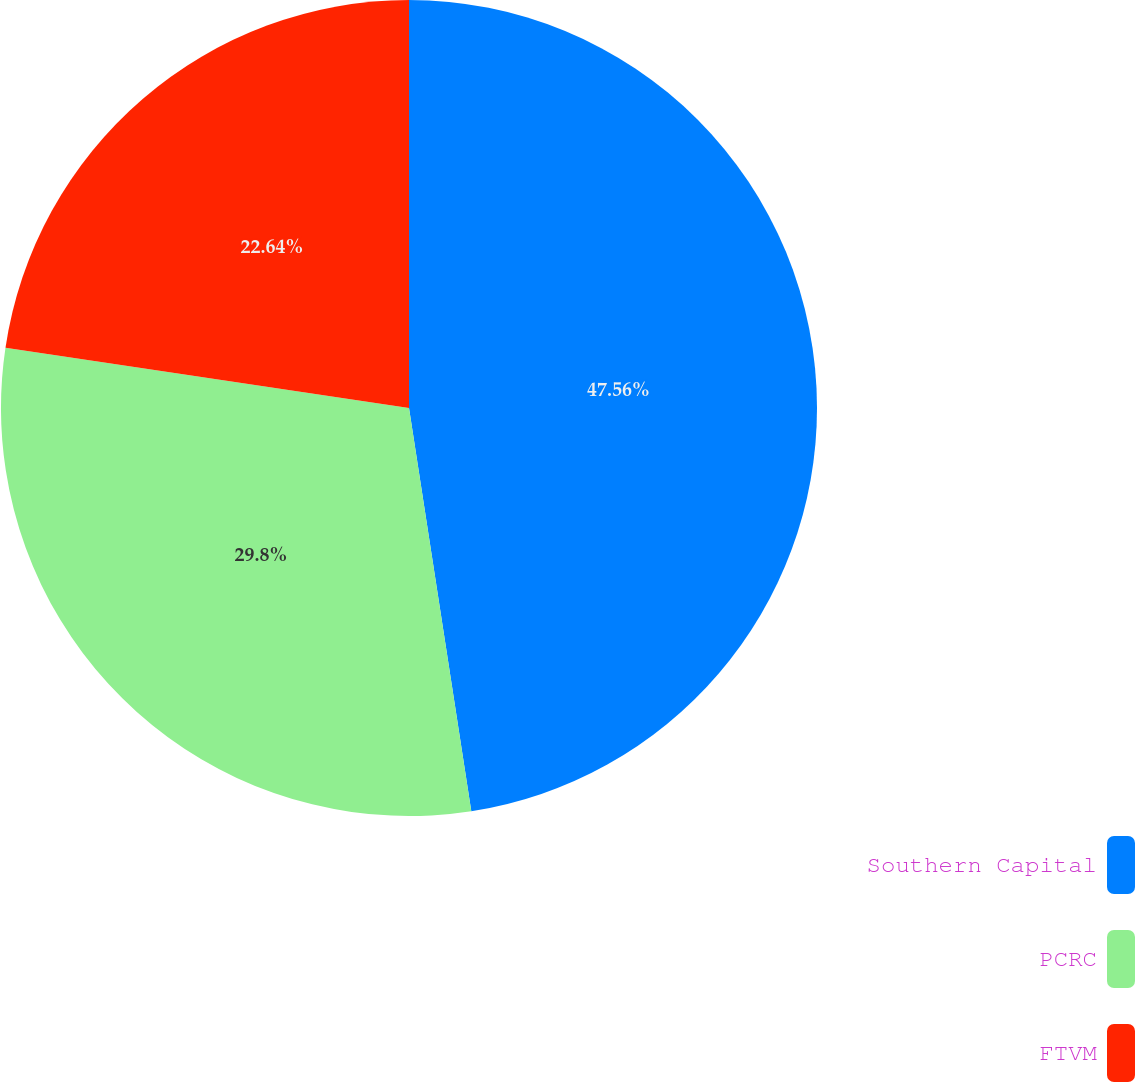Convert chart. <chart><loc_0><loc_0><loc_500><loc_500><pie_chart><fcel>Southern Capital<fcel>PCRC<fcel>FTVM<nl><fcel>47.56%<fcel>29.8%<fcel>22.64%<nl></chart> 